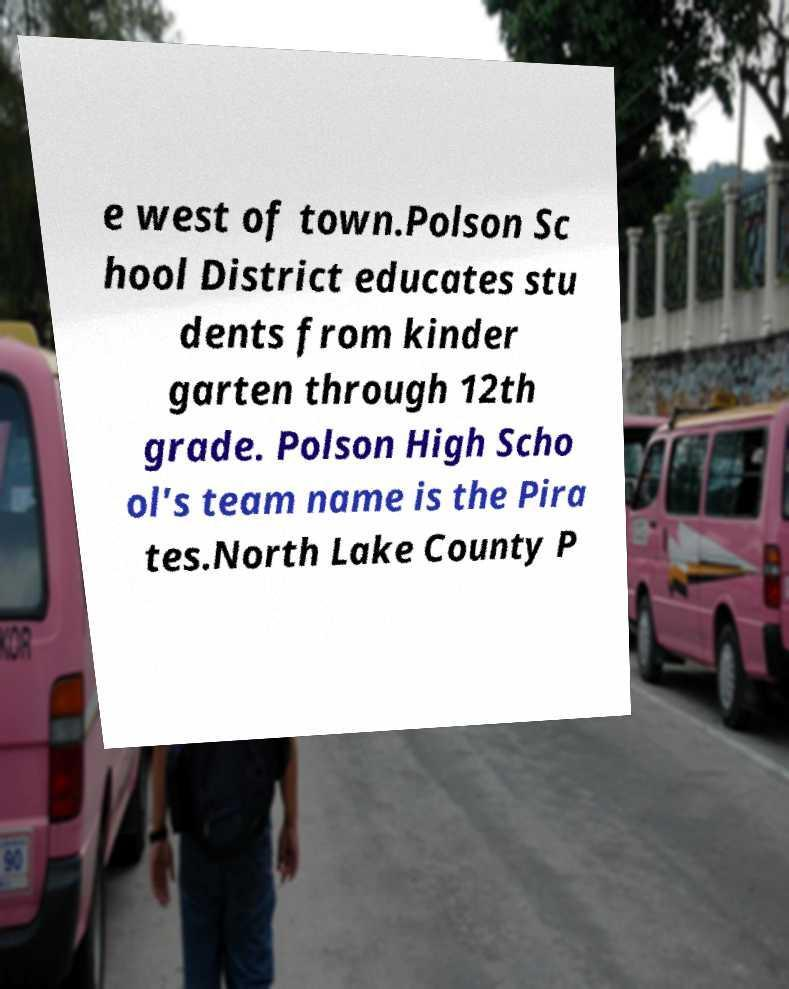I need the written content from this picture converted into text. Can you do that? e west of town.Polson Sc hool District educates stu dents from kinder garten through 12th grade. Polson High Scho ol's team name is the Pira tes.North Lake County P 